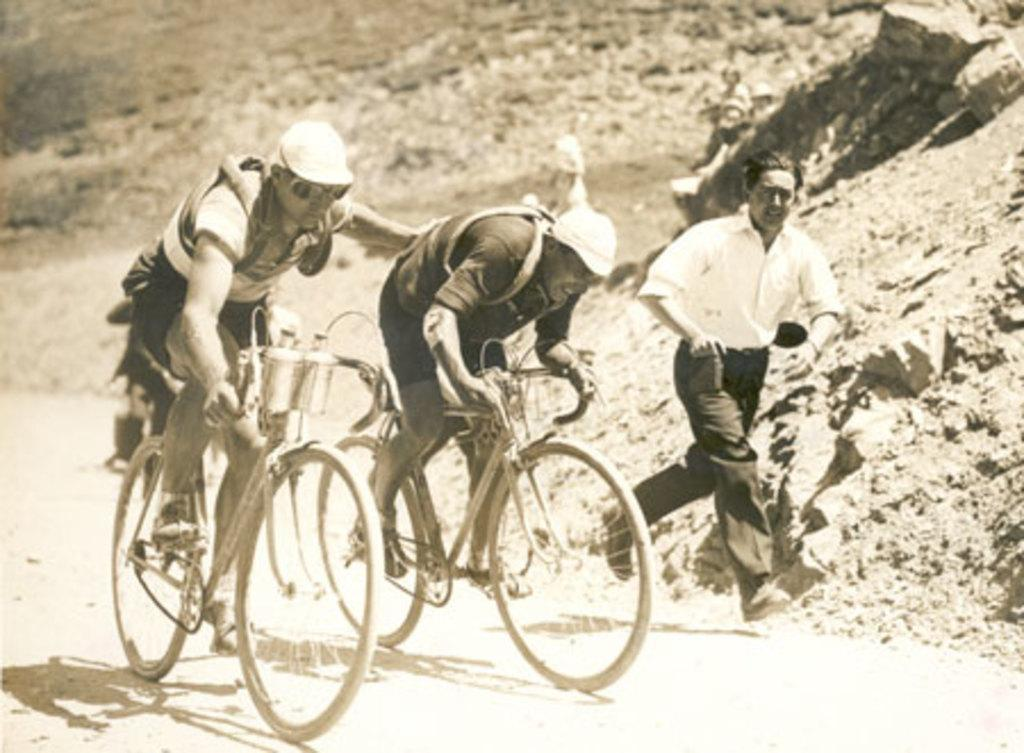What are the two persons riding bicycles on the road doing? The two persons riding bicycles on the road are riding their bicycles. What is the man in the image doing? The man in the image is running on the road. What can be seen in the background of the image? There is a rock hill in the background of the image. What type of lettuce can be seen growing on the rock hill in the image? There is no lettuce present in the image, and the rock hill does not appear to have any vegetation growing on it. 